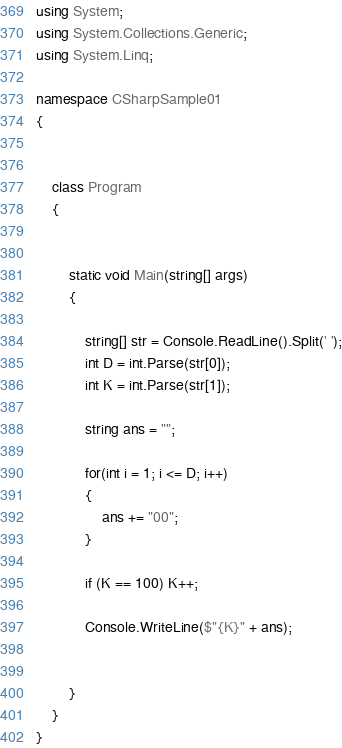<code> <loc_0><loc_0><loc_500><loc_500><_C#_>using System;
using System.Collections.Generic;
using System.Linq;

namespace CSharpSample01
{


    class Program
    {


        static void Main(string[] args)
        {

            string[] str = Console.ReadLine().Split(' ');
            int D = int.Parse(str[0]);
            int K = int.Parse(str[1]);

            string ans = "";           

            for(int i = 1; i <= D; i++)
            {
                ans += "00";
            }

            if (K == 100) K++;

            Console.WriteLine($"{K}" + ans);
            

        }
    }
}</code> 